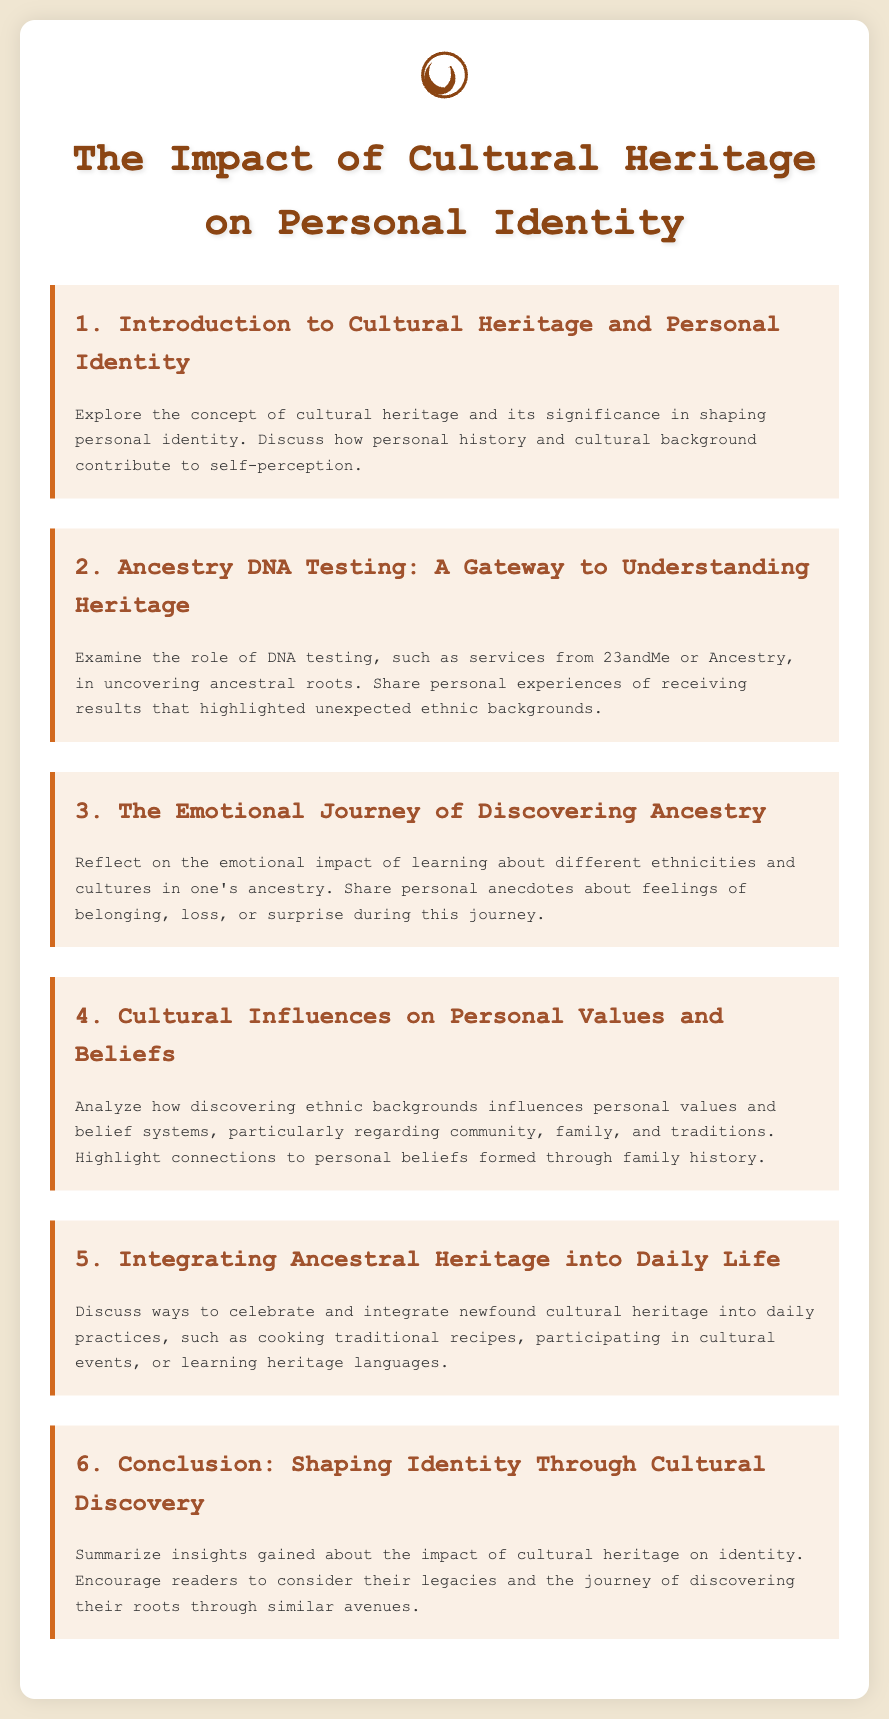What is the title of the document? The title is prominently displayed at the top of the document.
Answer: The Impact of Cultural Heritage on Personal Identity How many agenda items are listed? The number of agenda items can be counted in the document.
Answer: 6 What is the focus of the second agenda item? The second agenda item is specific about the role of DNA testing in understanding heritage.
Answer: Ancestry DNA Testing: A Gateway to Understanding Heritage What emotion is discussed in the third agenda item? The third agenda item reflects on an emotional aspect of ancestry discovery.
Answer: Emotional impact Which agenda item discusses the integration of cultural heritage into daily life? It is important to identify which agenda item is related to practical applications of cultural heritage.
Answer: 5 What are traditional practices mentioned in the fifth agenda item? The fifth agenda item specifies ways to celebrate newfound cultural heritage.
Answer: Cooking traditional recipes, participating in cultural events, learning heritage languages What does the conclusion in the document encourage readers to consider? The conclusion sums up the insights and encourages a specific action related to identity.
Answer: Their legacies and the journey of discovering their roots 